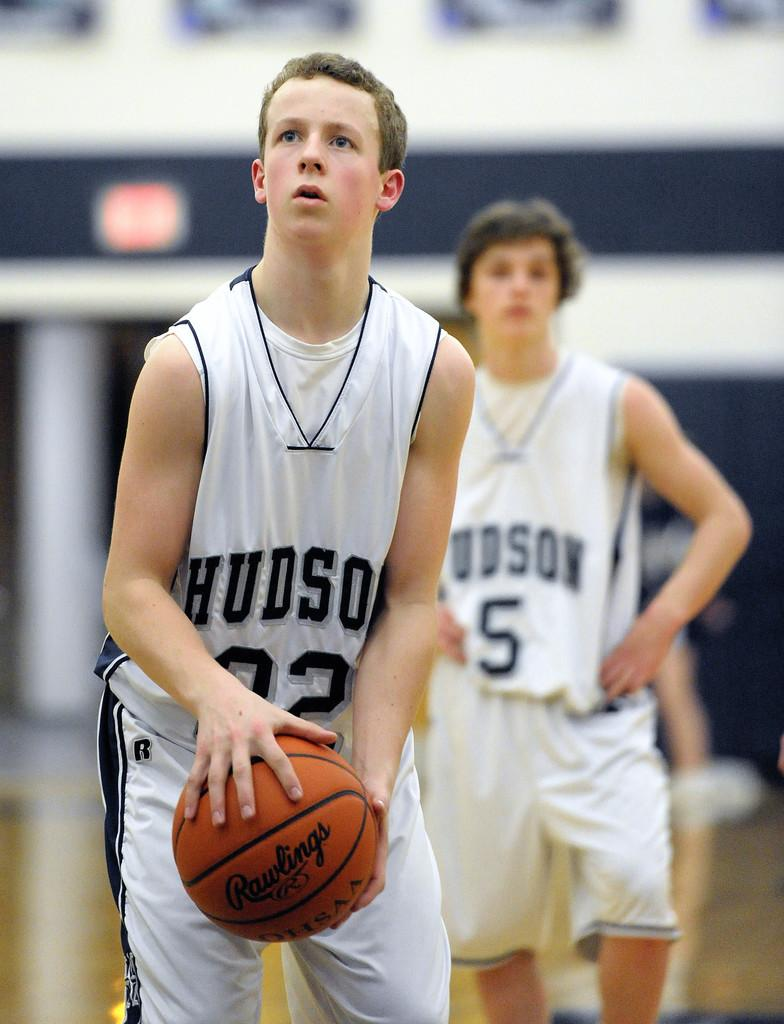<image>
Render a clear and concise summary of the photo. two members of the hudson baskebal team, playing with a rawlings ball 